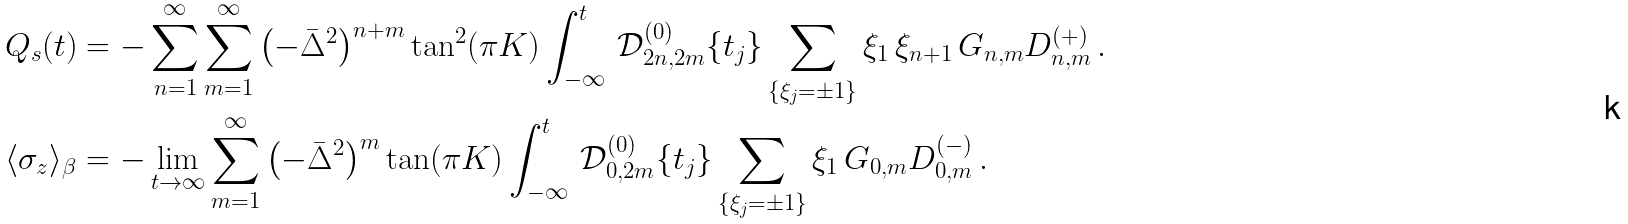Convert formula to latex. <formula><loc_0><loc_0><loc_500><loc_500>Q _ { s } ( t ) & = - \sum _ { n = 1 } ^ { \infty } \sum _ { m = 1 } ^ { \infty } \left ( - \bar { \Delta } ^ { 2 } \right ) ^ { n + m } \tan ^ { 2 } ( \pi K ) \int _ { - \infty } ^ { t } \, { \mathcal { D } } ^ { ( 0 ) } _ { 2 n , 2 m } \{ t _ { j } \} \sum _ { \{ \xi _ { j } = \pm 1 \} } \xi _ { 1 } \, \xi _ { n + 1 } \, G _ { n , m } D ^ { ( + ) } _ { n , m } \, . \\ \langle \sigma _ { z } \rangle _ { \beta } & = - \lim _ { t \to \infty } \sum _ { m = 1 } ^ { \infty } \left ( - \bar { \Delta } ^ { 2 } \right ) ^ { m } \tan ( \pi K ) \int _ { - \infty } ^ { t } \, { \mathcal { D } } ^ { ( 0 ) } _ { 0 , 2 m } \{ t _ { j } \} \sum _ { \{ \xi _ { j } = \pm 1 \} } \xi _ { 1 } \, G _ { 0 , m } D ^ { ( - ) } _ { 0 , m } \, .</formula> 